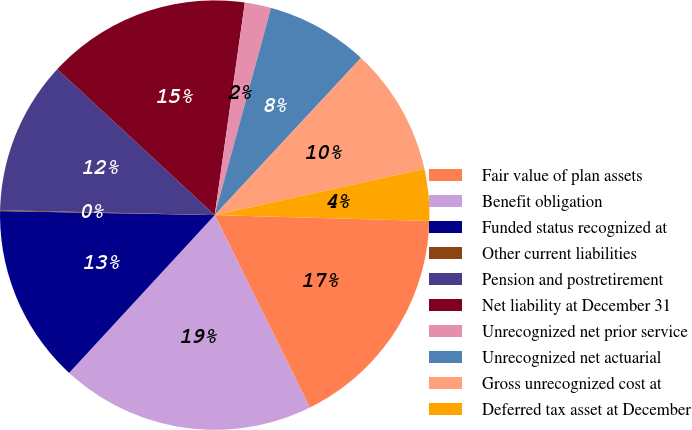Convert chart. <chart><loc_0><loc_0><loc_500><loc_500><pie_chart><fcel>Fair value of plan assets<fcel>Benefit obligation<fcel>Funded status recognized at<fcel>Other current liabilities<fcel>Pension and postretirement<fcel>Net liability at December 31<fcel>Unrecognized net prior service<fcel>Unrecognized net actuarial<fcel>Gross unrecognized cost at<fcel>Deferred tax asset at December<nl><fcel>17.26%<fcel>19.17%<fcel>13.44%<fcel>0.07%<fcel>11.53%<fcel>15.35%<fcel>1.98%<fcel>7.71%<fcel>9.62%<fcel>3.89%<nl></chart> 